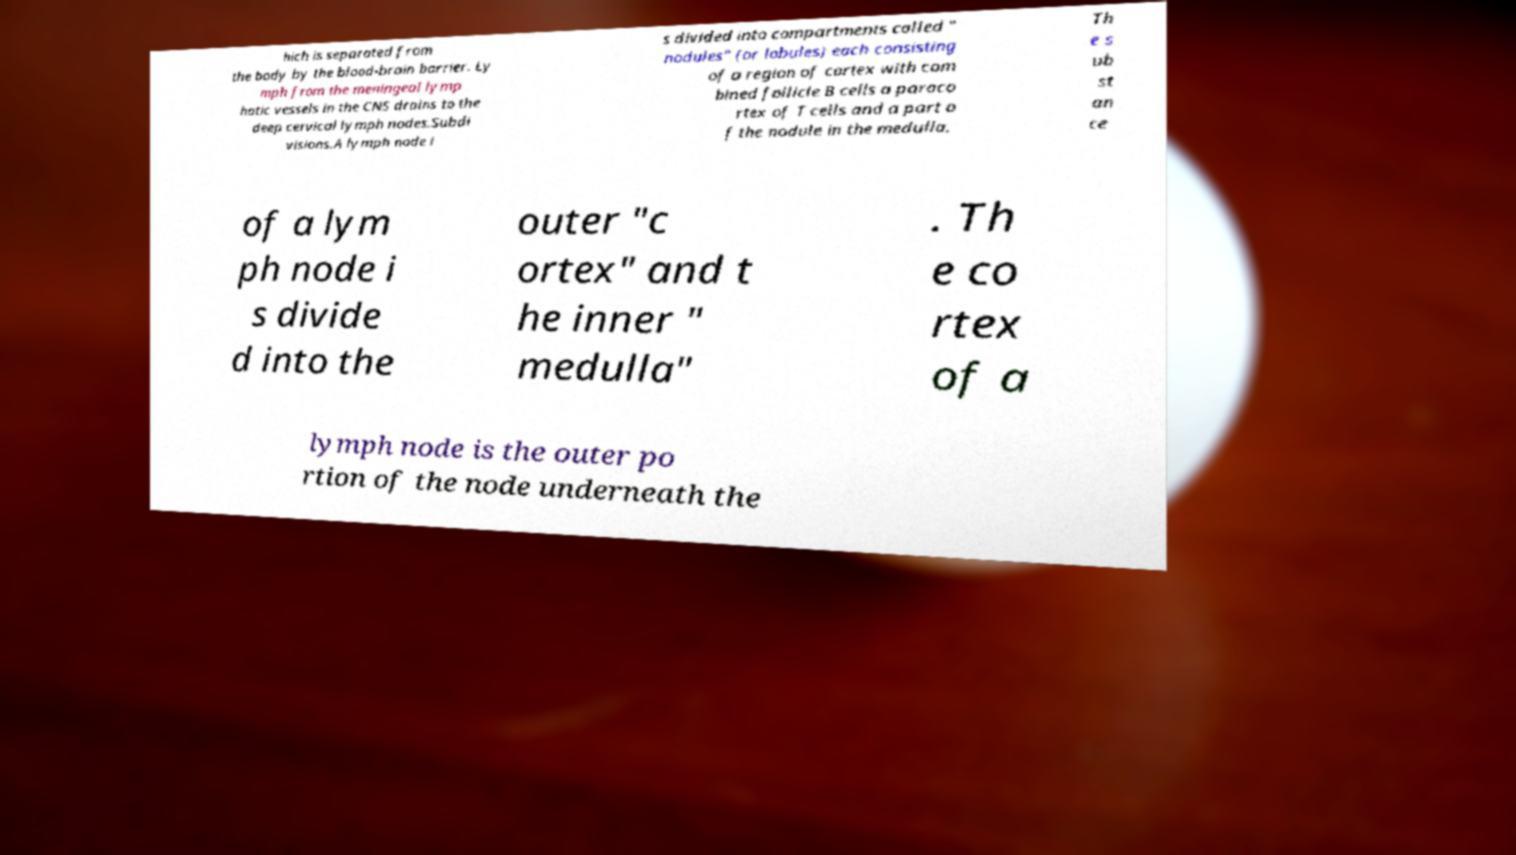Could you assist in decoding the text presented in this image and type it out clearly? hich is separated from the body by the blood-brain barrier. Ly mph from the meningeal lymp hatic vessels in the CNS drains to the deep cervical lymph nodes.Subdi visions.A lymph node i s divided into compartments called " nodules" (or lobules) each consisting of a region of cortex with com bined follicle B cells a paraco rtex of T cells and a part o f the nodule in the medulla. Th e s ub st an ce of a lym ph node i s divide d into the outer "c ortex" and t he inner " medulla" . Th e co rtex of a lymph node is the outer po rtion of the node underneath the 